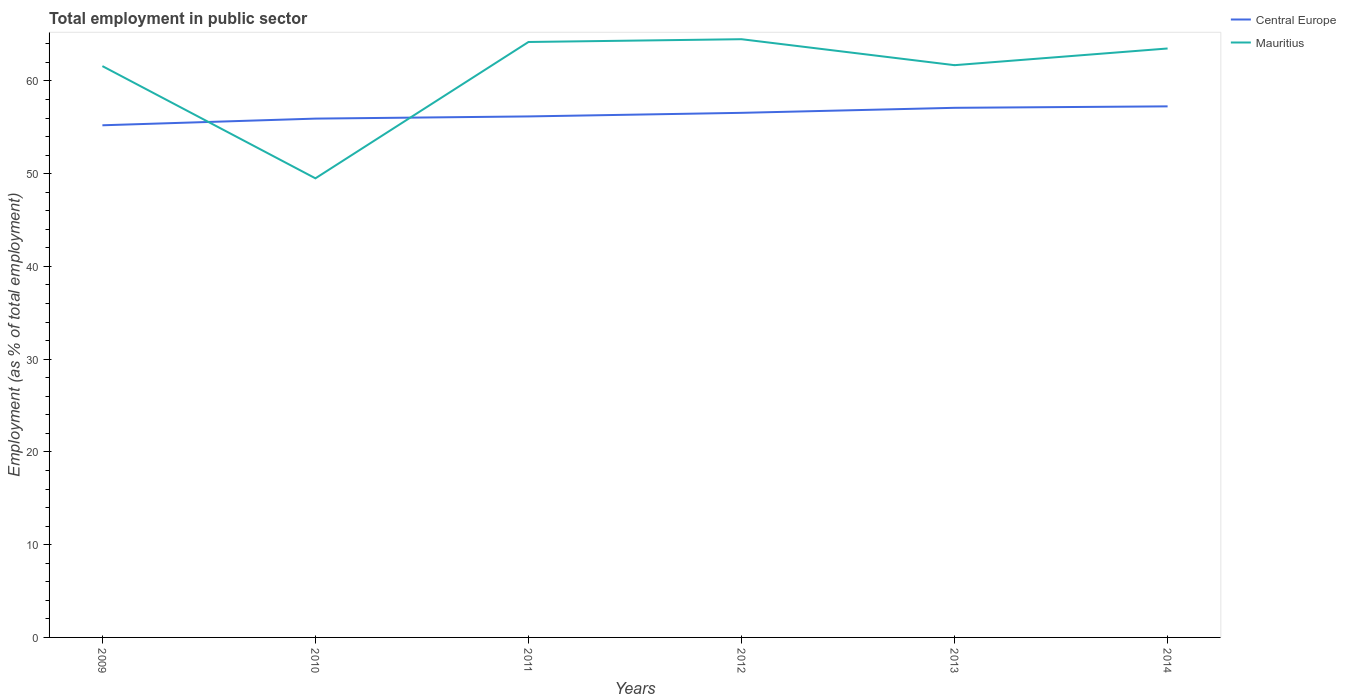How many different coloured lines are there?
Your answer should be very brief. 2. Does the line corresponding to Central Europe intersect with the line corresponding to Mauritius?
Make the answer very short. Yes. Is the number of lines equal to the number of legend labels?
Provide a short and direct response. Yes. Across all years, what is the maximum employment in public sector in Central Europe?
Provide a succinct answer. 55.22. What is the total employment in public sector in Central Europe in the graph?
Offer a very short reply. -0.16. What is the difference between the highest and the second highest employment in public sector in Central Europe?
Your response must be concise. 2.04. What is the difference between the highest and the lowest employment in public sector in Central Europe?
Give a very brief answer. 3. Is the employment in public sector in Central Europe strictly greater than the employment in public sector in Mauritius over the years?
Give a very brief answer. No. How many years are there in the graph?
Your answer should be very brief. 6. Does the graph contain any zero values?
Provide a succinct answer. No. Does the graph contain grids?
Provide a succinct answer. No. What is the title of the graph?
Your answer should be very brief. Total employment in public sector. What is the label or title of the X-axis?
Keep it short and to the point. Years. What is the label or title of the Y-axis?
Keep it short and to the point. Employment (as % of total employment). What is the Employment (as % of total employment) in Central Europe in 2009?
Offer a very short reply. 55.22. What is the Employment (as % of total employment) in Mauritius in 2009?
Your response must be concise. 61.6. What is the Employment (as % of total employment) of Central Europe in 2010?
Offer a terse response. 55.94. What is the Employment (as % of total employment) in Mauritius in 2010?
Offer a very short reply. 49.5. What is the Employment (as % of total employment) of Central Europe in 2011?
Give a very brief answer. 56.18. What is the Employment (as % of total employment) of Mauritius in 2011?
Provide a short and direct response. 64.2. What is the Employment (as % of total employment) in Central Europe in 2012?
Keep it short and to the point. 56.56. What is the Employment (as % of total employment) in Mauritius in 2012?
Give a very brief answer. 64.5. What is the Employment (as % of total employment) in Central Europe in 2013?
Provide a succinct answer. 57.1. What is the Employment (as % of total employment) of Mauritius in 2013?
Provide a succinct answer. 61.7. What is the Employment (as % of total employment) in Central Europe in 2014?
Offer a terse response. 57.26. What is the Employment (as % of total employment) in Mauritius in 2014?
Offer a very short reply. 63.5. Across all years, what is the maximum Employment (as % of total employment) of Central Europe?
Give a very brief answer. 57.26. Across all years, what is the maximum Employment (as % of total employment) in Mauritius?
Your response must be concise. 64.5. Across all years, what is the minimum Employment (as % of total employment) of Central Europe?
Keep it short and to the point. 55.22. Across all years, what is the minimum Employment (as % of total employment) of Mauritius?
Ensure brevity in your answer.  49.5. What is the total Employment (as % of total employment) of Central Europe in the graph?
Offer a very short reply. 338.26. What is the total Employment (as % of total employment) of Mauritius in the graph?
Provide a short and direct response. 365. What is the difference between the Employment (as % of total employment) of Central Europe in 2009 and that in 2010?
Keep it short and to the point. -0.72. What is the difference between the Employment (as % of total employment) of Central Europe in 2009 and that in 2011?
Offer a very short reply. -0.96. What is the difference between the Employment (as % of total employment) in Mauritius in 2009 and that in 2011?
Give a very brief answer. -2.6. What is the difference between the Employment (as % of total employment) in Central Europe in 2009 and that in 2012?
Your response must be concise. -1.34. What is the difference between the Employment (as % of total employment) in Central Europe in 2009 and that in 2013?
Your answer should be very brief. -1.88. What is the difference between the Employment (as % of total employment) of Mauritius in 2009 and that in 2013?
Your response must be concise. -0.1. What is the difference between the Employment (as % of total employment) in Central Europe in 2009 and that in 2014?
Offer a terse response. -2.04. What is the difference between the Employment (as % of total employment) in Central Europe in 2010 and that in 2011?
Your answer should be very brief. -0.24. What is the difference between the Employment (as % of total employment) of Mauritius in 2010 and that in 2011?
Your response must be concise. -14.7. What is the difference between the Employment (as % of total employment) in Central Europe in 2010 and that in 2012?
Offer a very short reply. -0.62. What is the difference between the Employment (as % of total employment) in Central Europe in 2010 and that in 2013?
Provide a succinct answer. -1.16. What is the difference between the Employment (as % of total employment) in Mauritius in 2010 and that in 2013?
Your response must be concise. -12.2. What is the difference between the Employment (as % of total employment) of Central Europe in 2010 and that in 2014?
Make the answer very short. -1.32. What is the difference between the Employment (as % of total employment) of Mauritius in 2010 and that in 2014?
Provide a short and direct response. -14. What is the difference between the Employment (as % of total employment) in Central Europe in 2011 and that in 2012?
Your response must be concise. -0.39. What is the difference between the Employment (as % of total employment) of Central Europe in 2011 and that in 2013?
Your answer should be compact. -0.93. What is the difference between the Employment (as % of total employment) in Central Europe in 2011 and that in 2014?
Provide a short and direct response. -1.09. What is the difference between the Employment (as % of total employment) of Central Europe in 2012 and that in 2013?
Your response must be concise. -0.54. What is the difference between the Employment (as % of total employment) in Central Europe in 2012 and that in 2014?
Provide a short and direct response. -0.7. What is the difference between the Employment (as % of total employment) in Central Europe in 2013 and that in 2014?
Your response must be concise. -0.16. What is the difference between the Employment (as % of total employment) in Mauritius in 2013 and that in 2014?
Offer a terse response. -1.8. What is the difference between the Employment (as % of total employment) in Central Europe in 2009 and the Employment (as % of total employment) in Mauritius in 2010?
Your answer should be very brief. 5.72. What is the difference between the Employment (as % of total employment) of Central Europe in 2009 and the Employment (as % of total employment) of Mauritius in 2011?
Offer a very short reply. -8.98. What is the difference between the Employment (as % of total employment) of Central Europe in 2009 and the Employment (as % of total employment) of Mauritius in 2012?
Your answer should be compact. -9.28. What is the difference between the Employment (as % of total employment) of Central Europe in 2009 and the Employment (as % of total employment) of Mauritius in 2013?
Make the answer very short. -6.48. What is the difference between the Employment (as % of total employment) of Central Europe in 2009 and the Employment (as % of total employment) of Mauritius in 2014?
Offer a very short reply. -8.28. What is the difference between the Employment (as % of total employment) of Central Europe in 2010 and the Employment (as % of total employment) of Mauritius in 2011?
Provide a succinct answer. -8.26. What is the difference between the Employment (as % of total employment) in Central Europe in 2010 and the Employment (as % of total employment) in Mauritius in 2012?
Keep it short and to the point. -8.56. What is the difference between the Employment (as % of total employment) of Central Europe in 2010 and the Employment (as % of total employment) of Mauritius in 2013?
Ensure brevity in your answer.  -5.76. What is the difference between the Employment (as % of total employment) in Central Europe in 2010 and the Employment (as % of total employment) in Mauritius in 2014?
Make the answer very short. -7.56. What is the difference between the Employment (as % of total employment) in Central Europe in 2011 and the Employment (as % of total employment) in Mauritius in 2012?
Make the answer very short. -8.32. What is the difference between the Employment (as % of total employment) of Central Europe in 2011 and the Employment (as % of total employment) of Mauritius in 2013?
Make the answer very short. -5.53. What is the difference between the Employment (as % of total employment) in Central Europe in 2011 and the Employment (as % of total employment) in Mauritius in 2014?
Keep it short and to the point. -7.33. What is the difference between the Employment (as % of total employment) in Central Europe in 2012 and the Employment (as % of total employment) in Mauritius in 2013?
Ensure brevity in your answer.  -5.14. What is the difference between the Employment (as % of total employment) in Central Europe in 2012 and the Employment (as % of total employment) in Mauritius in 2014?
Your response must be concise. -6.94. What is the difference between the Employment (as % of total employment) of Central Europe in 2013 and the Employment (as % of total employment) of Mauritius in 2014?
Your answer should be compact. -6.4. What is the average Employment (as % of total employment) in Central Europe per year?
Make the answer very short. 56.38. What is the average Employment (as % of total employment) in Mauritius per year?
Offer a very short reply. 60.83. In the year 2009, what is the difference between the Employment (as % of total employment) in Central Europe and Employment (as % of total employment) in Mauritius?
Provide a short and direct response. -6.38. In the year 2010, what is the difference between the Employment (as % of total employment) of Central Europe and Employment (as % of total employment) of Mauritius?
Your answer should be compact. 6.44. In the year 2011, what is the difference between the Employment (as % of total employment) in Central Europe and Employment (as % of total employment) in Mauritius?
Make the answer very short. -8.03. In the year 2012, what is the difference between the Employment (as % of total employment) of Central Europe and Employment (as % of total employment) of Mauritius?
Your answer should be compact. -7.94. In the year 2013, what is the difference between the Employment (as % of total employment) in Central Europe and Employment (as % of total employment) in Mauritius?
Provide a short and direct response. -4.6. In the year 2014, what is the difference between the Employment (as % of total employment) in Central Europe and Employment (as % of total employment) in Mauritius?
Ensure brevity in your answer.  -6.24. What is the ratio of the Employment (as % of total employment) in Central Europe in 2009 to that in 2010?
Offer a terse response. 0.99. What is the ratio of the Employment (as % of total employment) in Mauritius in 2009 to that in 2010?
Provide a short and direct response. 1.24. What is the ratio of the Employment (as % of total employment) of Mauritius in 2009 to that in 2011?
Make the answer very short. 0.96. What is the ratio of the Employment (as % of total employment) of Central Europe in 2009 to that in 2012?
Your answer should be very brief. 0.98. What is the ratio of the Employment (as % of total employment) in Mauritius in 2009 to that in 2012?
Your answer should be compact. 0.95. What is the ratio of the Employment (as % of total employment) in Mauritius in 2009 to that in 2013?
Offer a terse response. 1. What is the ratio of the Employment (as % of total employment) of Mauritius in 2009 to that in 2014?
Give a very brief answer. 0.97. What is the ratio of the Employment (as % of total employment) of Mauritius in 2010 to that in 2011?
Your answer should be very brief. 0.77. What is the ratio of the Employment (as % of total employment) in Mauritius in 2010 to that in 2012?
Ensure brevity in your answer.  0.77. What is the ratio of the Employment (as % of total employment) of Central Europe in 2010 to that in 2013?
Your response must be concise. 0.98. What is the ratio of the Employment (as % of total employment) of Mauritius in 2010 to that in 2013?
Offer a very short reply. 0.8. What is the ratio of the Employment (as % of total employment) of Central Europe in 2010 to that in 2014?
Provide a short and direct response. 0.98. What is the ratio of the Employment (as % of total employment) of Mauritius in 2010 to that in 2014?
Offer a terse response. 0.78. What is the ratio of the Employment (as % of total employment) of Central Europe in 2011 to that in 2013?
Provide a short and direct response. 0.98. What is the ratio of the Employment (as % of total employment) of Mauritius in 2011 to that in 2013?
Your answer should be compact. 1.04. What is the ratio of the Employment (as % of total employment) in Central Europe in 2011 to that in 2014?
Keep it short and to the point. 0.98. What is the ratio of the Employment (as % of total employment) of Central Europe in 2012 to that in 2013?
Provide a succinct answer. 0.99. What is the ratio of the Employment (as % of total employment) in Mauritius in 2012 to that in 2013?
Provide a short and direct response. 1.05. What is the ratio of the Employment (as % of total employment) of Mauritius in 2012 to that in 2014?
Your answer should be very brief. 1.02. What is the ratio of the Employment (as % of total employment) in Central Europe in 2013 to that in 2014?
Make the answer very short. 1. What is the ratio of the Employment (as % of total employment) of Mauritius in 2013 to that in 2014?
Your answer should be very brief. 0.97. What is the difference between the highest and the second highest Employment (as % of total employment) in Central Europe?
Make the answer very short. 0.16. What is the difference between the highest and the second highest Employment (as % of total employment) of Mauritius?
Provide a short and direct response. 0.3. What is the difference between the highest and the lowest Employment (as % of total employment) in Central Europe?
Offer a very short reply. 2.04. 